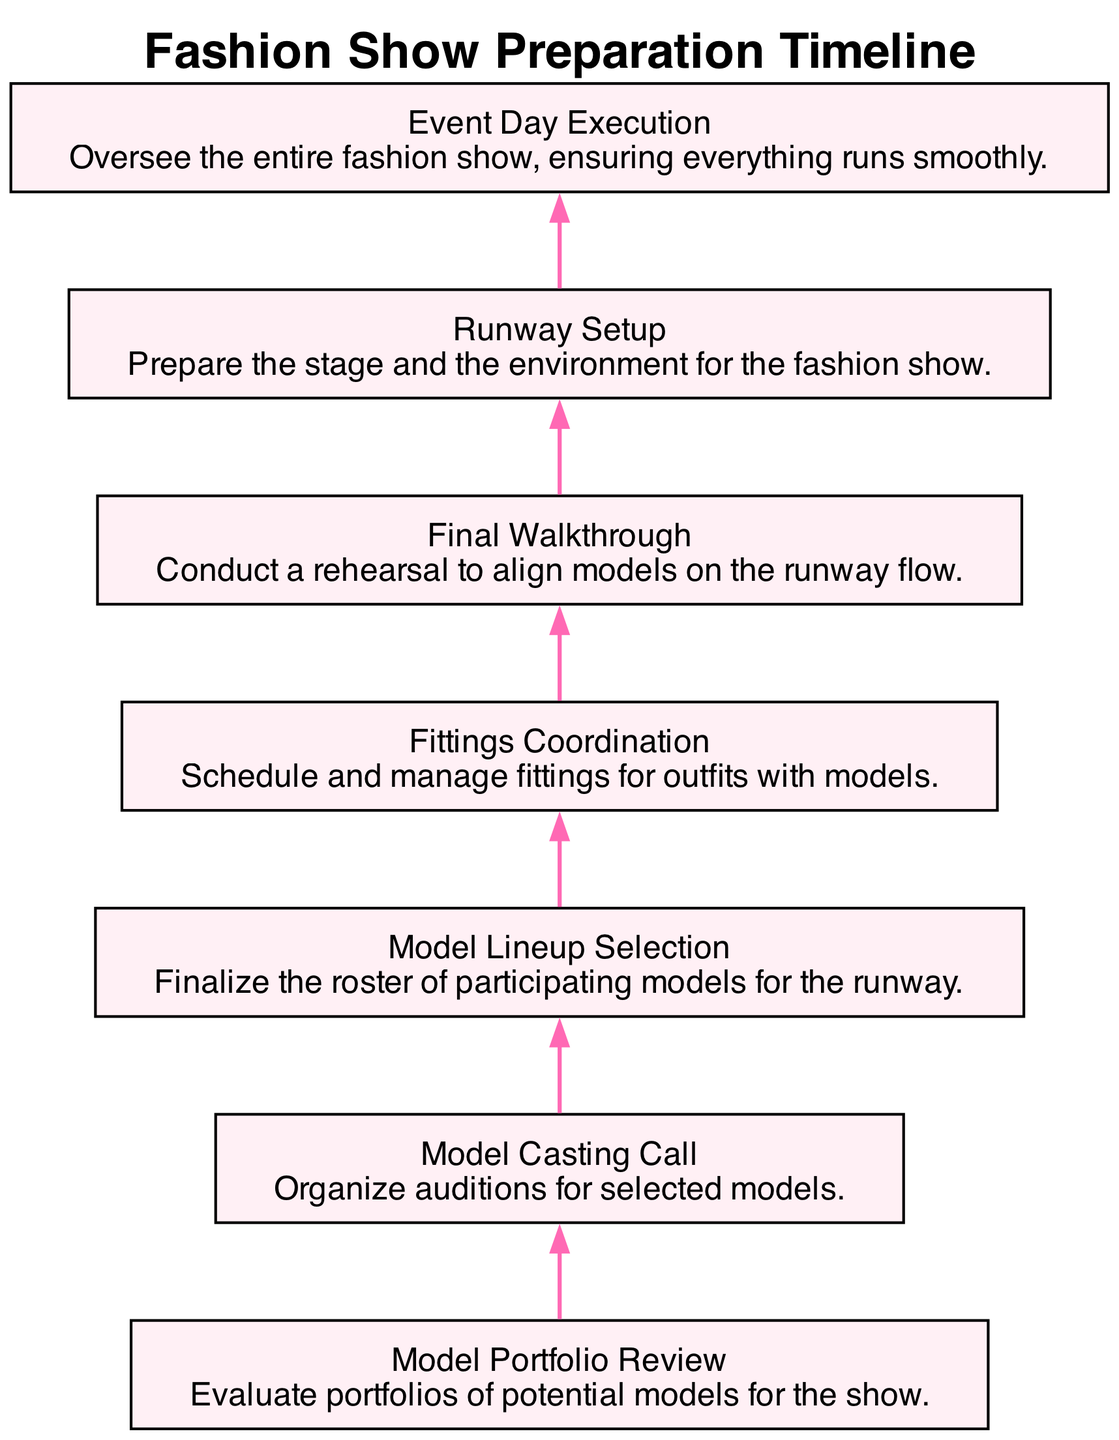What is the first task listed in the diagram? The diagram begins with "Model Portfolio Review," as it is the first node at the bottom of the flowchart.
Answer: Model Portfolio Review How many tasks are in the timeline? There are a total of 7 tasks listed in the diagram, each connected sequentially.
Answer: 7 What follows "Model Casting Call" in the preparation timeline? After "Model Casting Call," the next task is "Model Lineup Selection," which is the next node in the sequence.
Answer: Model Lineup Selection Which task occurs right before "Event Day Execution"? "Final Walkthrough" occurs directly before "Event Day Execution," as indicated by the direct connection in the flowchart.
Answer: Final Walkthrough What is the purpose of the "Fittings Coordination" task? "Fittings Coordination" is described as scheduling and managing fittings for outfits with models, which can be found in the task's description in the diagram.
Answer: Schedule and manage fittings for outfits with models How many edges connect the tasks in the diagram? Each task is connected by a single edge to the next, resulting in a total of 6 edges connecting the 7 tasks.
Answer: 6 Which task is related to preparing the stage for the fashion show? "Runway Setup" is the task related to preparing the stage and environment for the fashion show, as described in its node.
Answer: Runway Setup What is the last task in the preparation sequence? The last task in the preparation sequence is "Event Day Execution," as it is the final node at the top of the flowchart.
Answer: Event Day Execution Which task is a rehearsal for runway flow? "Final Walkthrough" is the task that serves as a rehearsal to align models on the runway flow, as indicated in the diagram description.
Answer: Final Walkthrough 